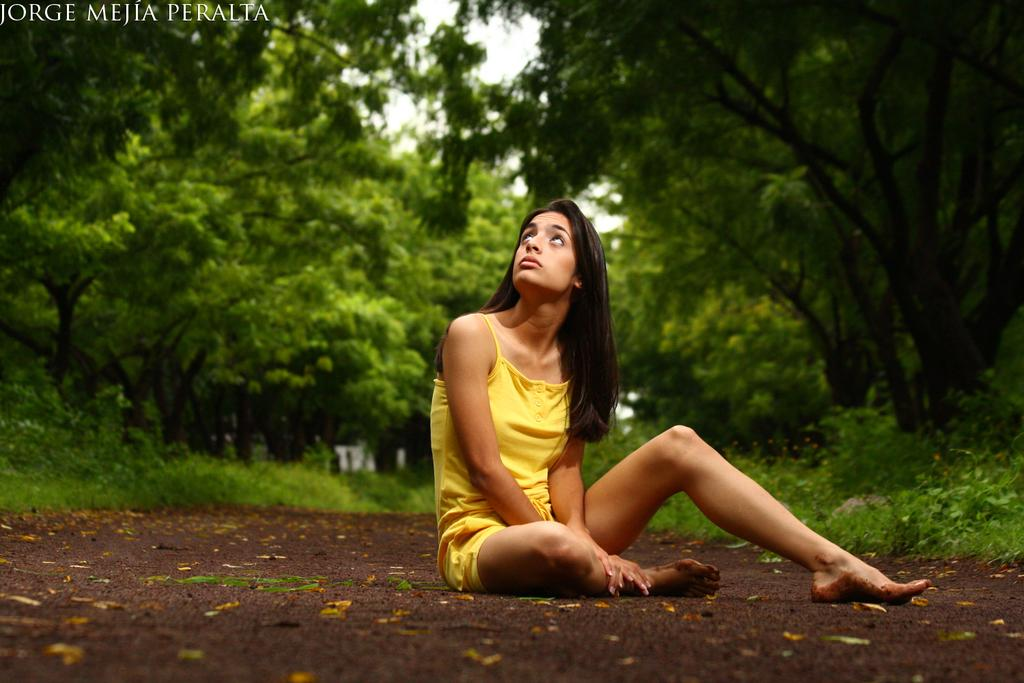Who is the main subject in the image? There is a lady in the image. What is the lady wearing? The lady is wearing a yellow dress. What is the lady's position in the image? The lady is sitting on the floor. What can be seen in the background of the image? There are plants and trees in the background of the image. What time does the clock show in the image? There is no clock present in the image. How many ducks are swimming in the pond in the image? There is no pond or ducks present in the image. 